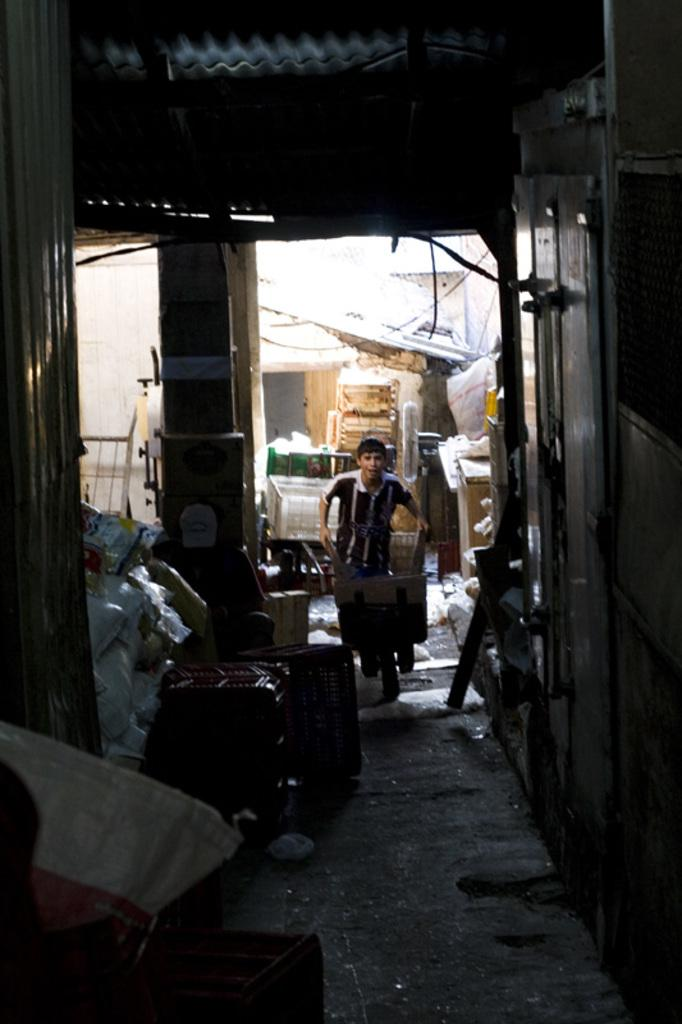Who is present in the image? There is a man in the image. What items can be seen near the man? There are bags in the image. What architectural features are visible in the image? There are pillars in the image. What can be seen in the background of the image? There are objects in the background of the image. What type of duck can be seen swimming in the image? There is no duck present in the image. What time of day is depicted in the image? The time of day cannot be determined from the image. 